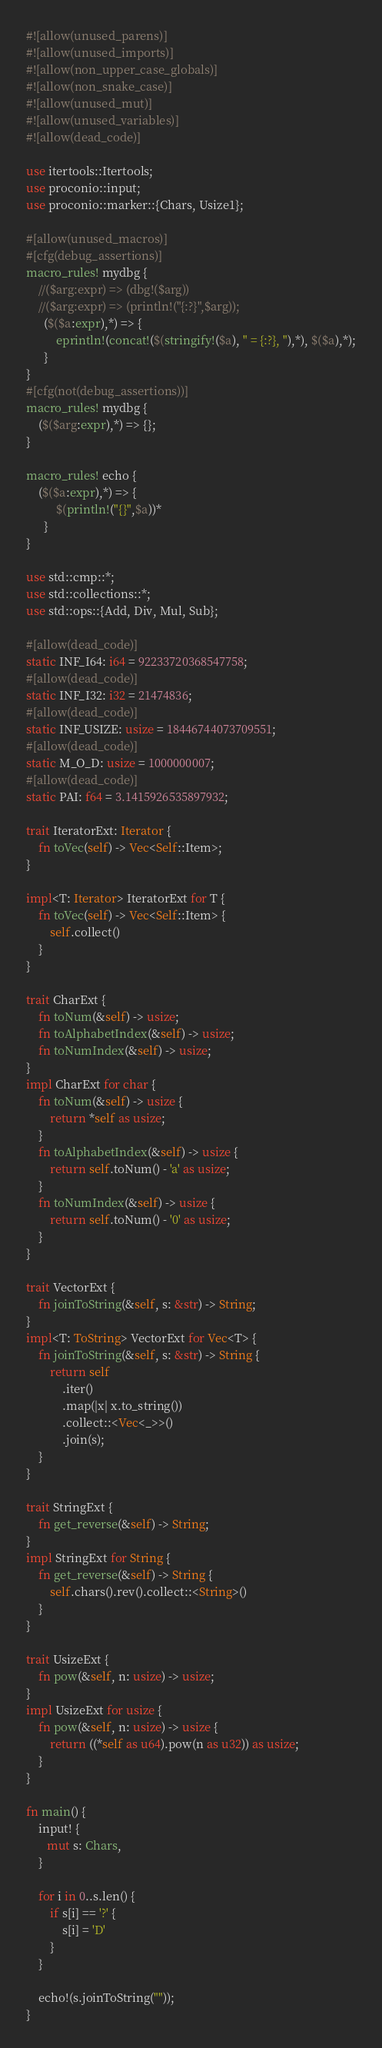<code> <loc_0><loc_0><loc_500><loc_500><_Rust_>#![allow(unused_parens)]
#![allow(unused_imports)]
#![allow(non_upper_case_globals)]
#![allow(non_snake_case)]
#![allow(unused_mut)]
#![allow(unused_variables)]
#![allow(dead_code)]

use itertools::Itertools;
use proconio::input;
use proconio::marker::{Chars, Usize1};

#[allow(unused_macros)]
#[cfg(debug_assertions)]
macro_rules! mydbg {
    //($arg:expr) => (dbg!($arg))
    //($arg:expr) => (println!("{:?}",$arg));
      ($($a:expr),*) => {
          eprintln!(concat!($(stringify!($a), " = {:?}, "),*), $($a),*);
      }
}
#[cfg(not(debug_assertions))]
macro_rules! mydbg {
    ($($arg:expr),*) => {};
}

macro_rules! echo {
    ($($a:expr),*) => {
          $(println!("{}",$a))*
      }
}

use std::cmp::*;
use std::collections::*;
use std::ops::{Add, Div, Mul, Sub};

#[allow(dead_code)]
static INF_I64: i64 = 92233720368547758;
#[allow(dead_code)]
static INF_I32: i32 = 21474836;
#[allow(dead_code)]
static INF_USIZE: usize = 18446744073709551;
#[allow(dead_code)]
static M_O_D: usize = 1000000007;
#[allow(dead_code)]
static PAI: f64 = 3.1415926535897932;

trait IteratorExt: Iterator {
    fn toVec(self) -> Vec<Self::Item>;
}

impl<T: Iterator> IteratorExt for T {
    fn toVec(self) -> Vec<Self::Item> {
        self.collect()
    }
}

trait CharExt {
    fn toNum(&self) -> usize;
    fn toAlphabetIndex(&self) -> usize;
    fn toNumIndex(&self) -> usize;
}
impl CharExt for char {
    fn toNum(&self) -> usize {
        return *self as usize;
    }
    fn toAlphabetIndex(&self) -> usize {
        return self.toNum() - 'a' as usize;
    }
    fn toNumIndex(&self) -> usize {
        return self.toNum() - '0' as usize;
    }
}

trait VectorExt {
    fn joinToString(&self, s: &str) -> String;
}
impl<T: ToString> VectorExt for Vec<T> {
    fn joinToString(&self, s: &str) -> String {
        return self
            .iter()
            .map(|x| x.to_string())
            .collect::<Vec<_>>()
            .join(s);
    }
}

trait StringExt {
    fn get_reverse(&self) -> String;
}
impl StringExt for String {
    fn get_reverse(&self) -> String {
        self.chars().rev().collect::<String>()
    }
}

trait UsizeExt {
    fn pow(&self, n: usize) -> usize;
}
impl UsizeExt for usize {
    fn pow(&self, n: usize) -> usize {
        return ((*self as u64).pow(n as u32)) as usize;
    }
}

fn main() {
    input! {
       mut s: Chars,
    }

    for i in 0..s.len() {
        if s[i] == '?' {
            s[i] = 'D'
        }
    }

    echo!(s.joinToString(""));
}
</code> 